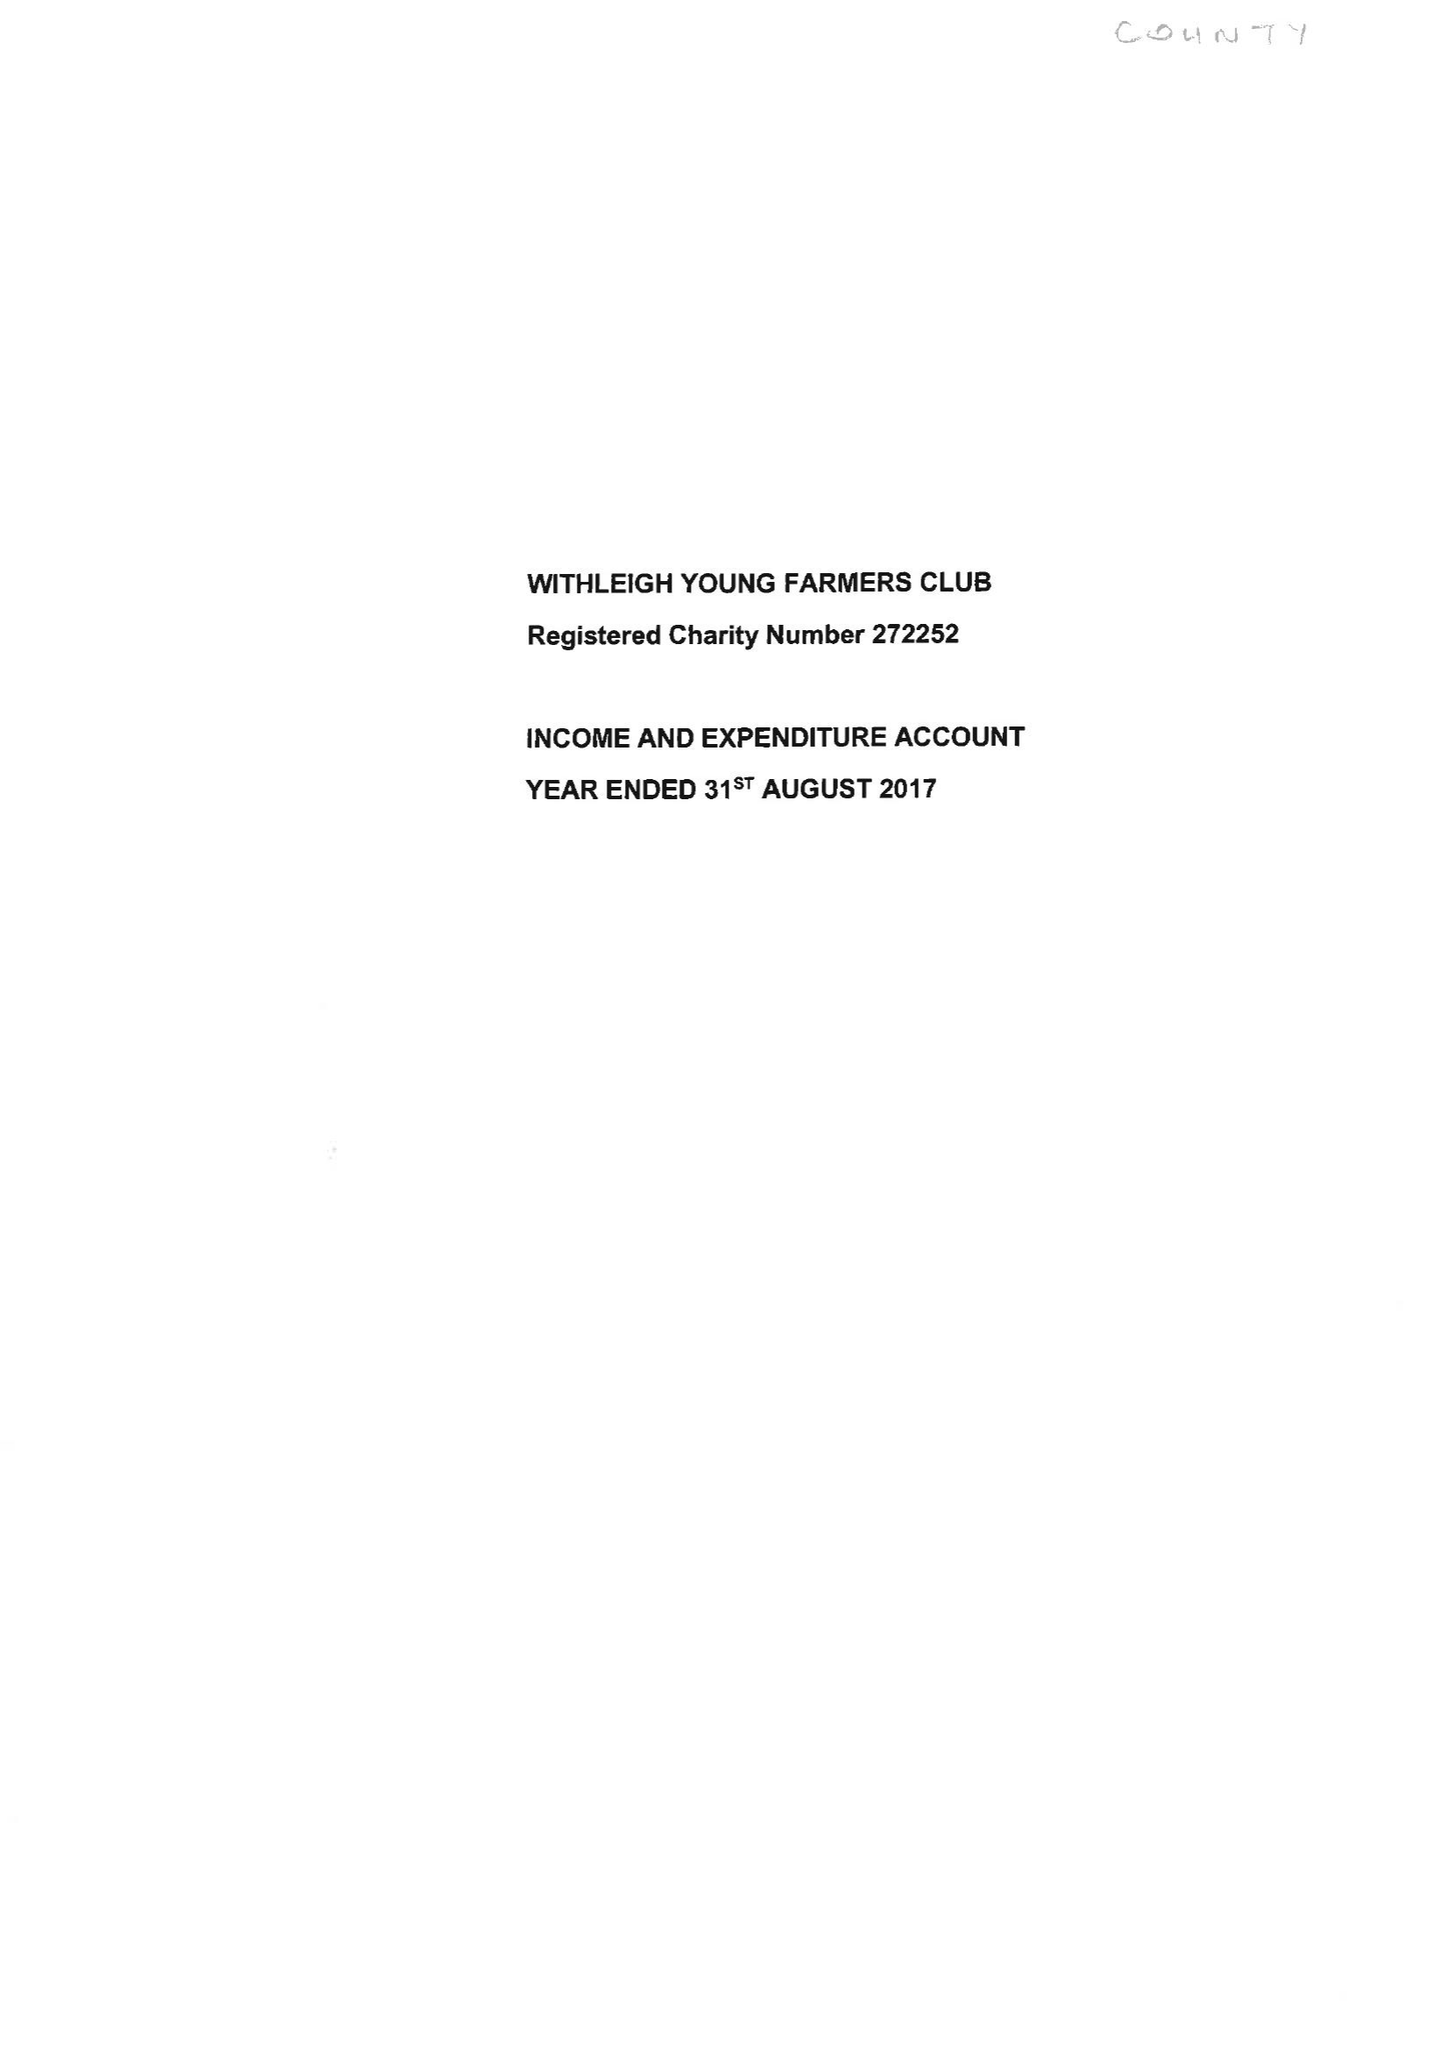What is the value for the income_annually_in_british_pounds?
Answer the question using a single word or phrase. 32383.00 